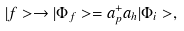<formula> <loc_0><loc_0><loc_500><loc_500>| f > \rightarrow | \Phi _ { f } > = a _ { p } ^ { + } a _ { h } | \Phi _ { i } > ,</formula> 